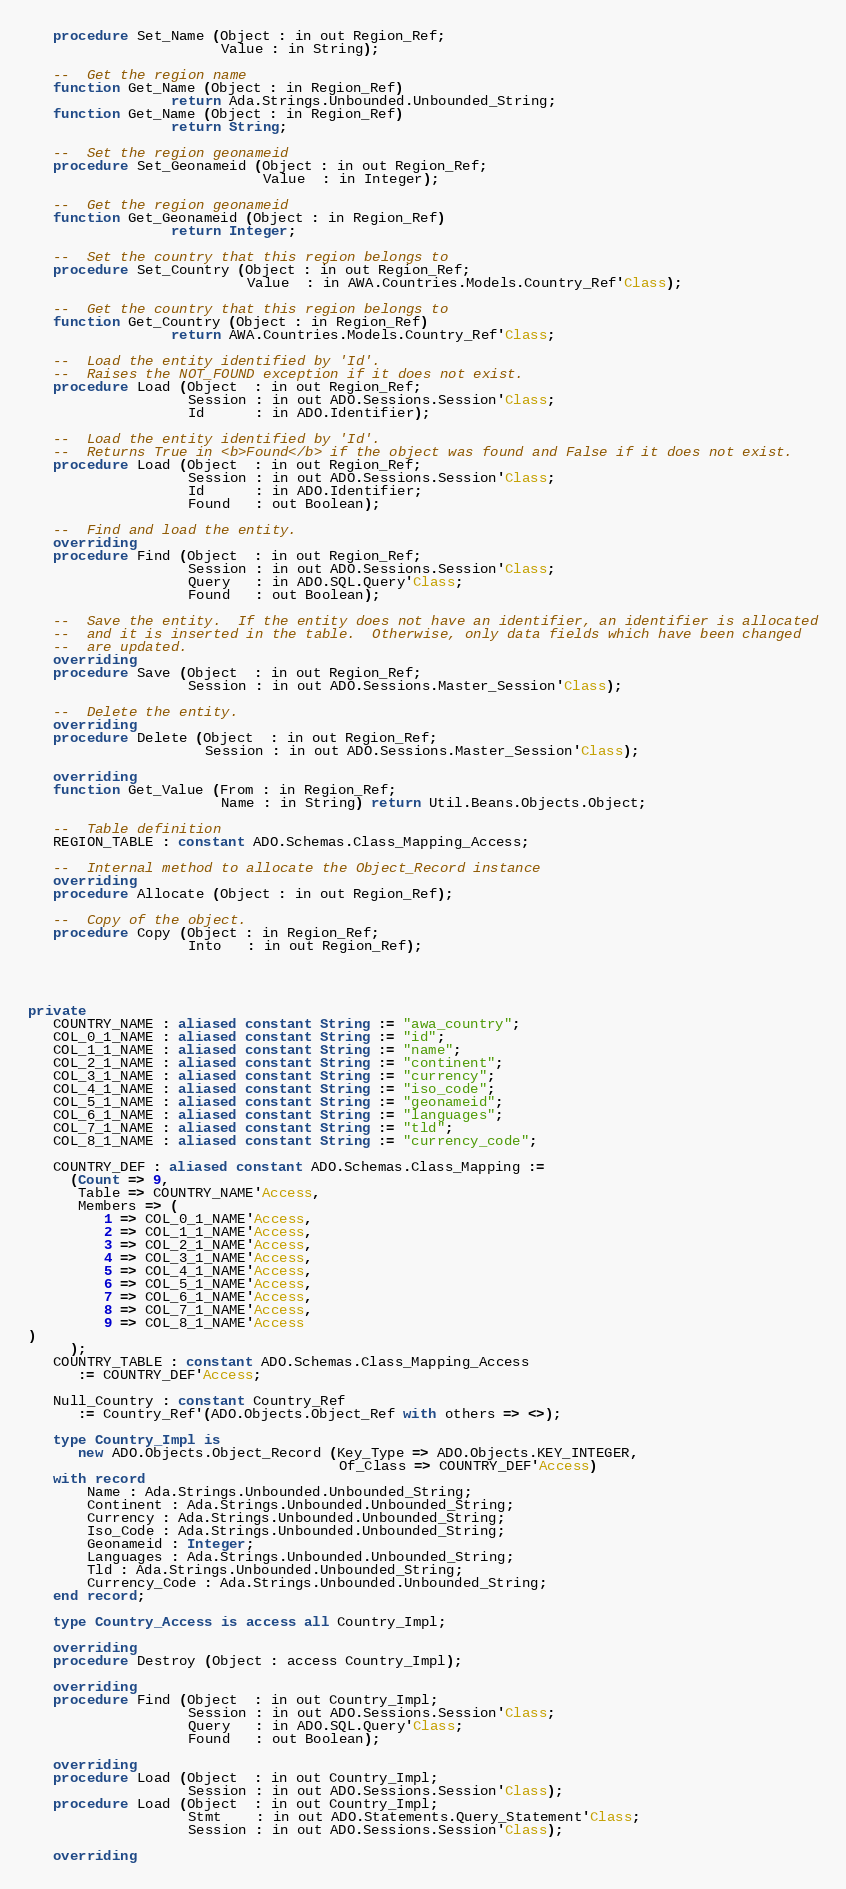Convert code to text. <code><loc_0><loc_0><loc_500><loc_500><_Ada_>   procedure Set_Name (Object : in out Region_Ref;
                       Value : in String);

   --  Get the region name
   function Get_Name (Object : in Region_Ref)
                 return Ada.Strings.Unbounded.Unbounded_String;
   function Get_Name (Object : in Region_Ref)
                 return String;

   --  Set the region geonameid
   procedure Set_Geonameid (Object : in out Region_Ref;
                            Value  : in Integer);

   --  Get the region geonameid
   function Get_Geonameid (Object : in Region_Ref)
                 return Integer;

   --  Set the country that this region belongs to
   procedure Set_Country (Object : in out Region_Ref;
                          Value  : in AWA.Countries.Models.Country_Ref'Class);

   --  Get the country that this region belongs to
   function Get_Country (Object : in Region_Ref)
                 return AWA.Countries.Models.Country_Ref'Class;

   --  Load the entity identified by 'Id'.
   --  Raises the NOT_FOUND exception if it does not exist.
   procedure Load (Object  : in out Region_Ref;
                   Session : in out ADO.Sessions.Session'Class;
                   Id      : in ADO.Identifier);

   --  Load the entity identified by 'Id'.
   --  Returns True in <b>Found</b> if the object was found and False if it does not exist.
   procedure Load (Object  : in out Region_Ref;
                   Session : in out ADO.Sessions.Session'Class;
                   Id      : in ADO.Identifier;
                   Found   : out Boolean);

   --  Find and load the entity.
   overriding
   procedure Find (Object  : in out Region_Ref;
                   Session : in out ADO.Sessions.Session'Class;
                   Query   : in ADO.SQL.Query'Class;
                   Found   : out Boolean);

   --  Save the entity.  If the entity does not have an identifier, an identifier is allocated
   --  and it is inserted in the table.  Otherwise, only data fields which have been changed
   --  are updated.
   overriding
   procedure Save (Object  : in out Region_Ref;
                   Session : in out ADO.Sessions.Master_Session'Class);

   --  Delete the entity.
   overriding
   procedure Delete (Object  : in out Region_Ref;
                     Session : in out ADO.Sessions.Master_Session'Class);

   overriding
   function Get_Value (From : in Region_Ref;
                       Name : in String) return Util.Beans.Objects.Object;

   --  Table definition
   REGION_TABLE : constant ADO.Schemas.Class_Mapping_Access;

   --  Internal method to allocate the Object_Record instance
   overriding
   procedure Allocate (Object : in out Region_Ref);

   --  Copy of the object.
   procedure Copy (Object : in Region_Ref;
                   Into   : in out Region_Ref);




private
   COUNTRY_NAME : aliased constant String := "awa_country";
   COL_0_1_NAME : aliased constant String := "id";
   COL_1_1_NAME : aliased constant String := "name";
   COL_2_1_NAME : aliased constant String := "continent";
   COL_3_1_NAME : aliased constant String := "currency";
   COL_4_1_NAME : aliased constant String := "iso_code";
   COL_5_1_NAME : aliased constant String := "geonameid";
   COL_6_1_NAME : aliased constant String := "languages";
   COL_7_1_NAME : aliased constant String := "tld";
   COL_8_1_NAME : aliased constant String := "currency_code";

   COUNTRY_DEF : aliased constant ADO.Schemas.Class_Mapping :=
     (Count => 9,
      Table => COUNTRY_NAME'Access,
      Members => (
         1 => COL_0_1_NAME'Access,
         2 => COL_1_1_NAME'Access,
         3 => COL_2_1_NAME'Access,
         4 => COL_3_1_NAME'Access,
         5 => COL_4_1_NAME'Access,
         6 => COL_5_1_NAME'Access,
         7 => COL_6_1_NAME'Access,
         8 => COL_7_1_NAME'Access,
         9 => COL_8_1_NAME'Access
)
     );
   COUNTRY_TABLE : constant ADO.Schemas.Class_Mapping_Access
      := COUNTRY_DEF'Access;

   Null_Country : constant Country_Ref
      := Country_Ref'(ADO.Objects.Object_Ref with others => <>);

   type Country_Impl is
      new ADO.Objects.Object_Record (Key_Type => ADO.Objects.KEY_INTEGER,
                                     Of_Class => COUNTRY_DEF'Access)
   with record
       Name : Ada.Strings.Unbounded.Unbounded_String;
       Continent : Ada.Strings.Unbounded.Unbounded_String;
       Currency : Ada.Strings.Unbounded.Unbounded_String;
       Iso_Code : Ada.Strings.Unbounded.Unbounded_String;
       Geonameid : Integer;
       Languages : Ada.Strings.Unbounded.Unbounded_String;
       Tld : Ada.Strings.Unbounded.Unbounded_String;
       Currency_Code : Ada.Strings.Unbounded.Unbounded_String;
   end record;

   type Country_Access is access all Country_Impl;

   overriding
   procedure Destroy (Object : access Country_Impl);

   overriding
   procedure Find (Object  : in out Country_Impl;
                   Session : in out ADO.Sessions.Session'Class;
                   Query   : in ADO.SQL.Query'Class;
                   Found   : out Boolean);

   overriding
   procedure Load (Object  : in out Country_Impl;
                   Session : in out ADO.Sessions.Session'Class);
   procedure Load (Object  : in out Country_Impl;
                   Stmt    : in out ADO.Statements.Query_Statement'Class;
                   Session : in out ADO.Sessions.Session'Class);

   overriding</code> 